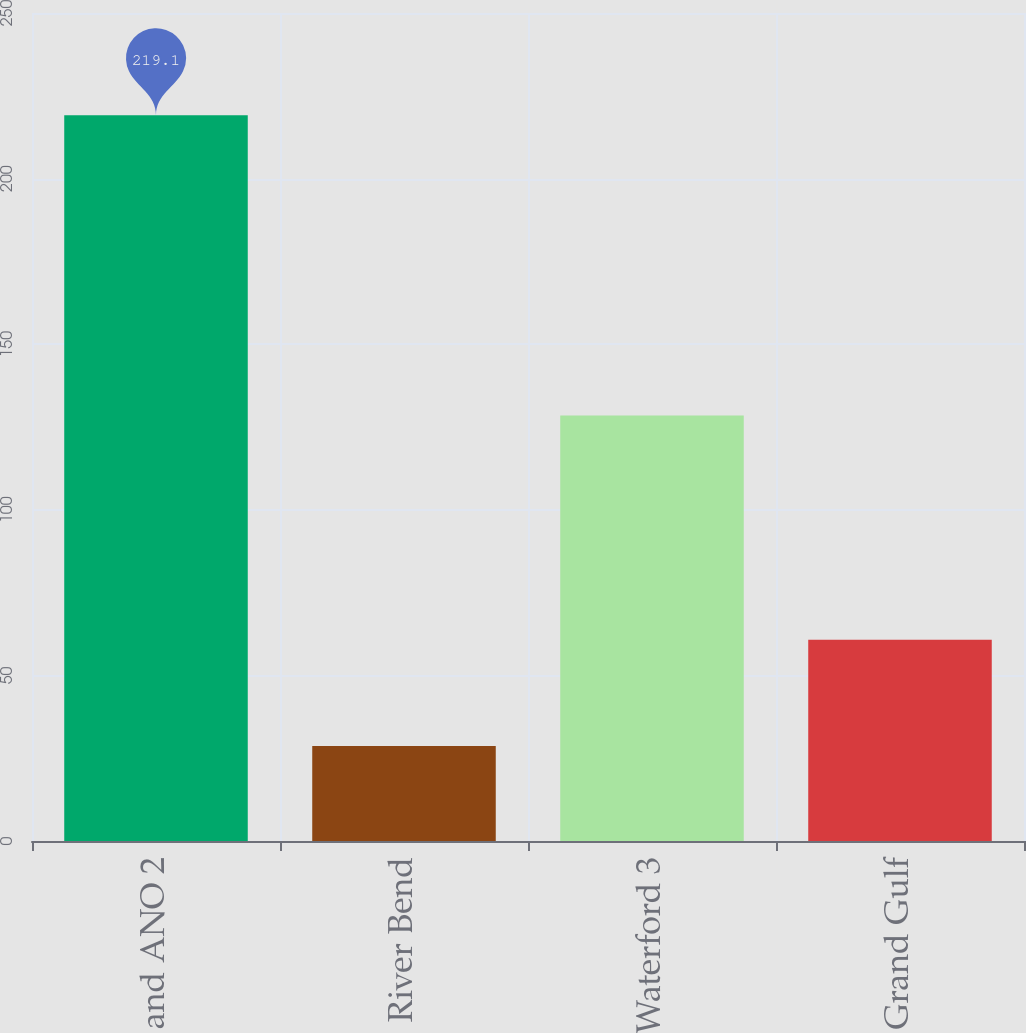Convert chart to OTSL. <chart><loc_0><loc_0><loc_500><loc_500><bar_chart><fcel>ANO 1 and ANO 2<fcel>River Bend<fcel>Waterford 3<fcel>Grand Gulf<nl><fcel>219.1<fcel>28.7<fcel>128.5<fcel>60.8<nl></chart> 